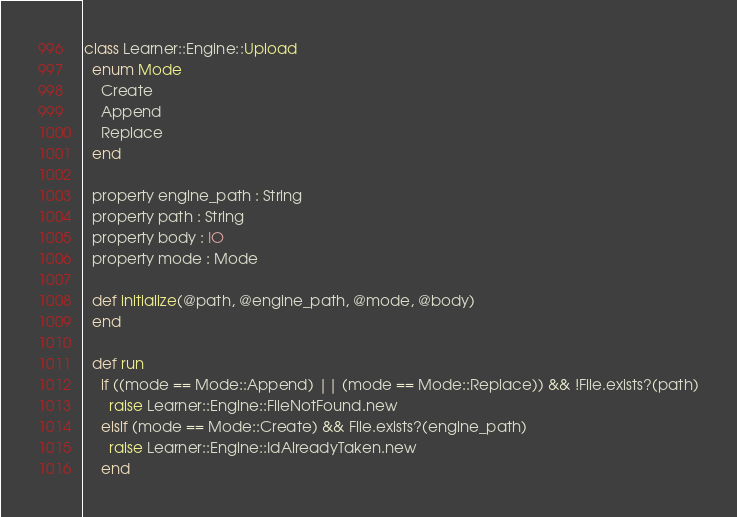<code> <loc_0><loc_0><loc_500><loc_500><_Crystal_>class Learner::Engine::Upload
  enum Mode
    Create
    Append
    Replace
  end

  property engine_path : String
  property path : String
  property body : IO
  property mode : Mode

  def initialize(@path, @engine_path, @mode, @body)
  end

  def run
    if ((mode == Mode::Append) || (mode == Mode::Replace)) && !File.exists?(path)
      raise Learner::Engine::FileNotFound.new
    elsif (mode == Mode::Create) && File.exists?(engine_path)
      raise Learner::Engine::IdAlreadyTaken.new
    end</code> 